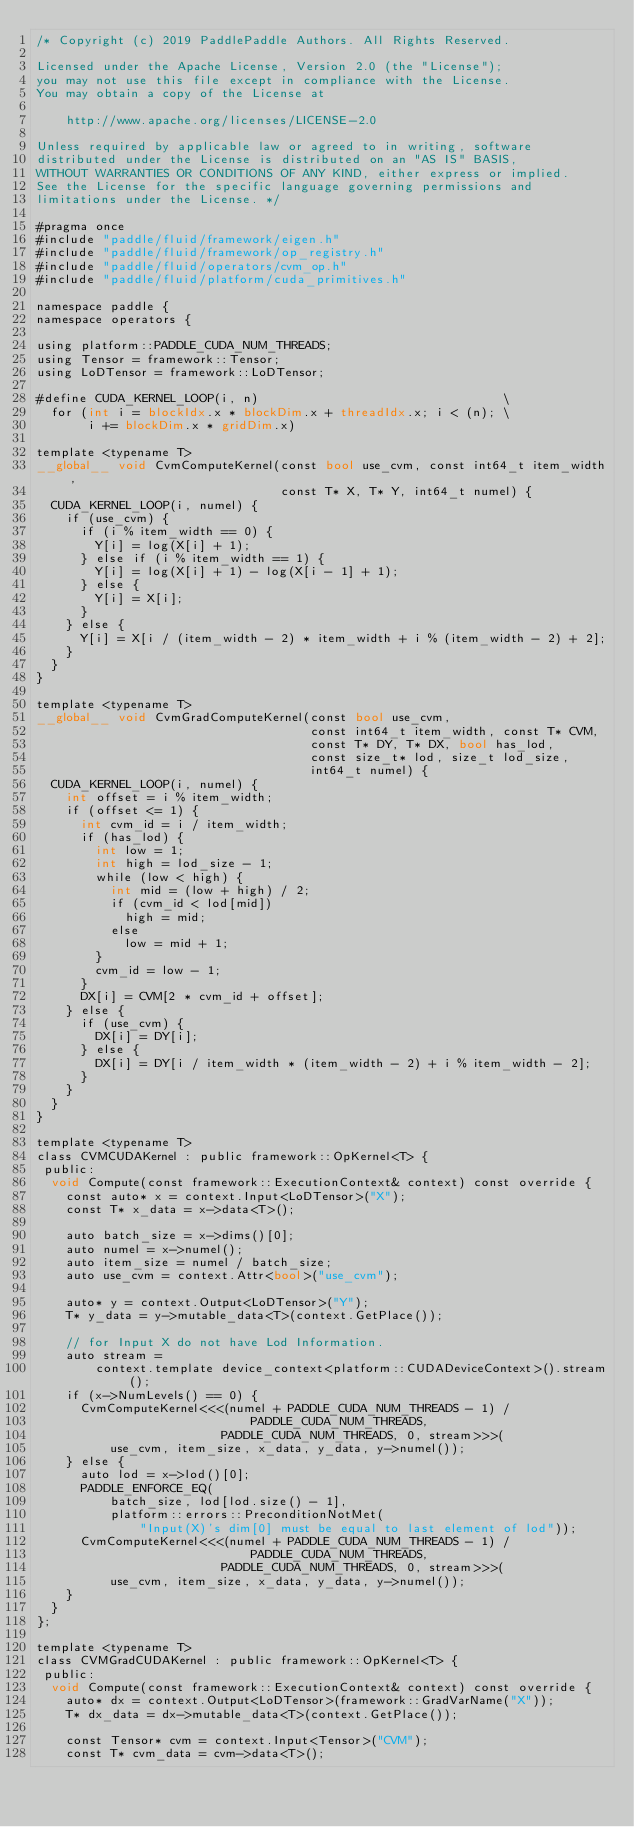Convert code to text. <code><loc_0><loc_0><loc_500><loc_500><_Cuda_>/* Copyright (c) 2019 PaddlePaddle Authors. All Rights Reserved.

Licensed under the Apache License, Version 2.0 (the "License");
you may not use this file except in compliance with the License.
You may obtain a copy of the License at

    http://www.apache.org/licenses/LICENSE-2.0

Unless required by applicable law or agreed to in writing, software
distributed under the License is distributed on an "AS IS" BASIS,
WITHOUT WARRANTIES OR CONDITIONS OF ANY KIND, either express or implied.
See the License for the specific language governing permissions and
limitations under the License. */

#pragma once
#include "paddle/fluid/framework/eigen.h"
#include "paddle/fluid/framework/op_registry.h"
#include "paddle/fluid/operators/cvm_op.h"
#include "paddle/fluid/platform/cuda_primitives.h"

namespace paddle {
namespace operators {

using platform::PADDLE_CUDA_NUM_THREADS;
using Tensor = framework::Tensor;
using LoDTensor = framework::LoDTensor;

#define CUDA_KERNEL_LOOP(i, n)                                 \
  for (int i = blockIdx.x * blockDim.x + threadIdx.x; i < (n); \
       i += blockDim.x * gridDim.x)

template <typename T>
__global__ void CvmComputeKernel(const bool use_cvm, const int64_t item_width,
                                 const T* X, T* Y, int64_t numel) {
  CUDA_KERNEL_LOOP(i, numel) {
    if (use_cvm) {
      if (i % item_width == 0) {
        Y[i] = log(X[i] + 1);
      } else if (i % item_width == 1) {
        Y[i] = log(X[i] + 1) - log(X[i - 1] + 1);
      } else {
        Y[i] = X[i];
      }
    } else {
      Y[i] = X[i / (item_width - 2) * item_width + i % (item_width - 2) + 2];
    }
  }
}

template <typename T>
__global__ void CvmGradComputeKernel(const bool use_cvm,
                                     const int64_t item_width, const T* CVM,
                                     const T* DY, T* DX, bool has_lod,
                                     const size_t* lod, size_t lod_size,
                                     int64_t numel) {
  CUDA_KERNEL_LOOP(i, numel) {
    int offset = i % item_width;
    if (offset <= 1) {
      int cvm_id = i / item_width;
      if (has_lod) {
        int low = 1;
        int high = lod_size - 1;
        while (low < high) {
          int mid = (low + high) / 2;
          if (cvm_id < lod[mid])
            high = mid;
          else
            low = mid + 1;
        }
        cvm_id = low - 1;
      }
      DX[i] = CVM[2 * cvm_id + offset];
    } else {
      if (use_cvm) {
        DX[i] = DY[i];
      } else {
        DX[i] = DY[i / item_width * (item_width - 2) + i % item_width - 2];
      }
    }
  }
}

template <typename T>
class CVMCUDAKernel : public framework::OpKernel<T> {
 public:
  void Compute(const framework::ExecutionContext& context) const override {
    const auto* x = context.Input<LoDTensor>("X");
    const T* x_data = x->data<T>();

    auto batch_size = x->dims()[0];
    auto numel = x->numel();
    auto item_size = numel / batch_size;
    auto use_cvm = context.Attr<bool>("use_cvm");

    auto* y = context.Output<LoDTensor>("Y");
    T* y_data = y->mutable_data<T>(context.GetPlace());

    // for Input X do not have Lod Information.
    auto stream =
        context.template device_context<platform::CUDADeviceContext>().stream();
    if (x->NumLevels() == 0) {
      CvmComputeKernel<<<(numel + PADDLE_CUDA_NUM_THREADS - 1) /
                             PADDLE_CUDA_NUM_THREADS,
                         PADDLE_CUDA_NUM_THREADS, 0, stream>>>(
          use_cvm, item_size, x_data, y_data, y->numel());
    } else {
      auto lod = x->lod()[0];
      PADDLE_ENFORCE_EQ(
          batch_size, lod[lod.size() - 1],
          platform::errors::PreconditionNotMet(
              "Input(X)'s dim[0] must be equal to last element of lod"));
      CvmComputeKernel<<<(numel + PADDLE_CUDA_NUM_THREADS - 1) /
                             PADDLE_CUDA_NUM_THREADS,
                         PADDLE_CUDA_NUM_THREADS, 0, stream>>>(
          use_cvm, item_size, x_data, y_data, y->numel());
    }
  }
};

template <typename T>
class CVMGradCUDAKernel : public framework::OpKernel<T> {
 public:
  void Compute(const framework::ExecutionContext& context) const override {
    auto* dx = context.Output<LoDTensor>(framework::GradVarName("X"));
    T* dx_data = dx->mutable_data<T>(context.GetPlace());

    const Tensor* cvm = context.Input<Tensor>("CVM");
    const T* cvm_data = cvm->data<T>();
</code> 